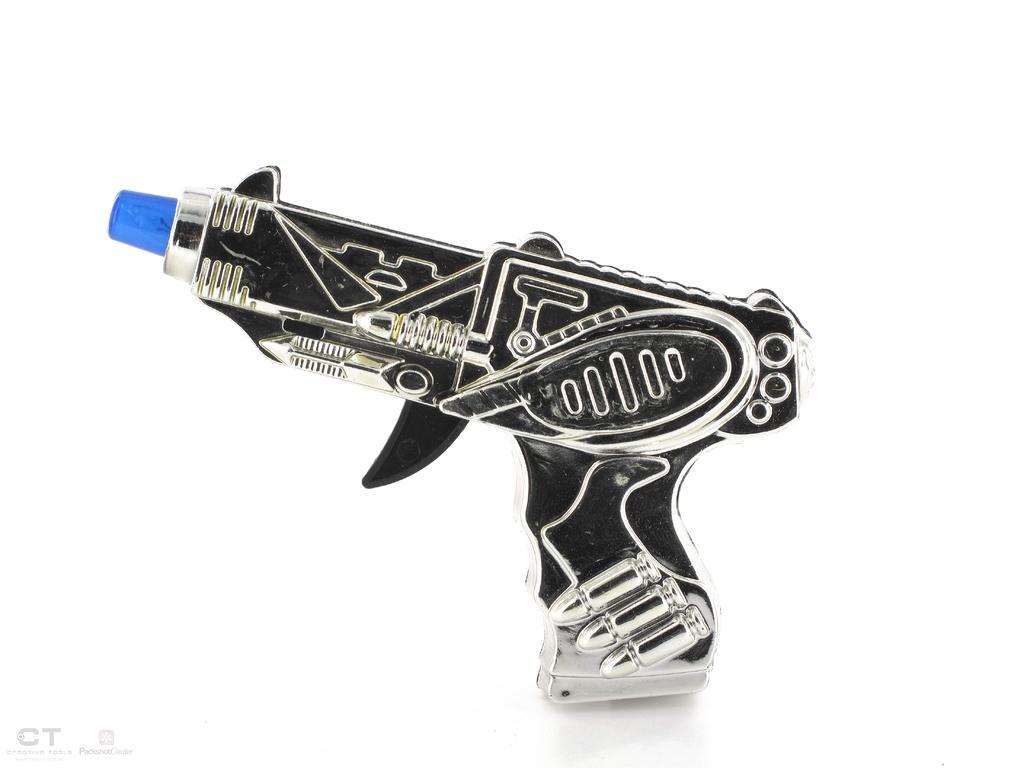In one or two sentences, can you explain what this image depicts? In this image there is a toy gun. 